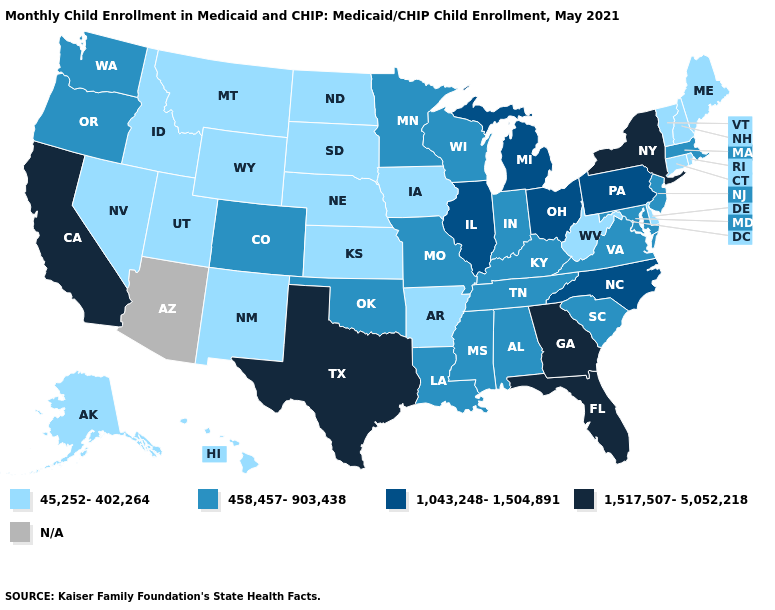Name the states that have a value in the range 45,252-402,264?
Quick response, please. Alaska, Arkansas, Connecticut, Delaware, Hawaii, Idaho, Iowa, Kansas, Maine, Montana, Nebraska, Nevada, New Hampshire, New Mexico, North Dakota, Rhode Island, South Dakota, Utah, Vermont, West Virginia, Wyoming. Does California have the lowest value in the West?
Keep it brief. No. Name the states that have a value in the range N/A?
Give a very brief answer. Arizona. Name the states that have a value in the range N/A?
Short answer required. Arizona. Which states have the highest value in the USA?
Answer briefly. California, Florida, Georgia, New York, Texas. Name the states that have a value in the range 1,043,248-1,504,891?
Give a very brief answer. Illinois, Michigan, North Carolina, Ohio, Pennsylvania. Does Missouri have the lowest value in the USA?
Give a very brief answer. No. Does California have the highest value in the West?
Give a very brief answer. Yes. Does the first symbol in the legend represent the smallest category?
Concise answer only. Yes. Name the states that have a value in the range 1,043,248-1,504,891?
Keep it brief. Illinois, Michigan, North Carolina, Ohio, Pennsylvania. Which states have the lowest value in the West?
Keep it brief. Alaska, Hawaii, Idaho, Montana, Nevada, New Mexico, Utah, Wyoming. What is the value of Colorado?
Write a very short answer. 458,457-903,438. What is the value of Connecticut?
Keep it brief. 45,252-402,264. 